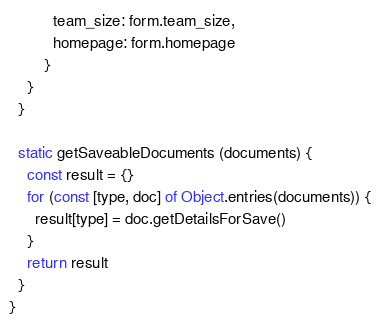<code> <loc_0><loc_0><loc_500><loc_500><_JavaScript_>          team_size: form.team_size,
          homepage: form.homepage
        }
    }
  }

  static getSaveableDocuments (documents) {
    const result = {}
    for (const [type, doc] of Object.entries(documents)) {
      result[type] = doc.getDetailsForSave()
    }
    return result
  }
}
</code> 